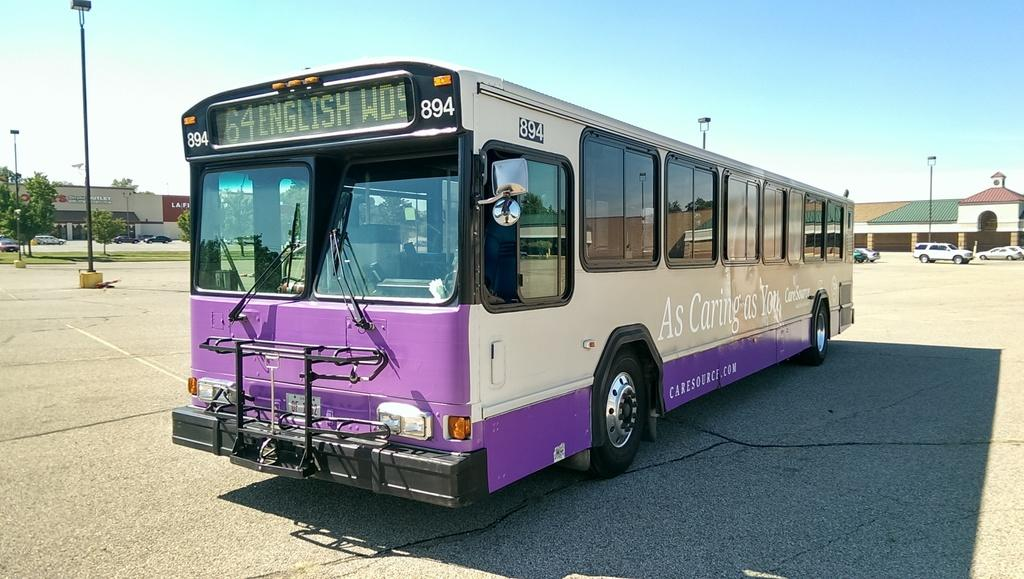What type of vehicle is on the road in the image? There is a bus on the road in the image. What is located behind the bus? There is a building behind the bus. Are there any other vehicles on the road in the image? Yes, there are cars on the road in the image. What structures can be seen along the road in the image? There are light poles in the image. What type of credit can be seen being given to the bus driver in the image? There is no credit being given to the bus driver in the image; it is a still photograph. 